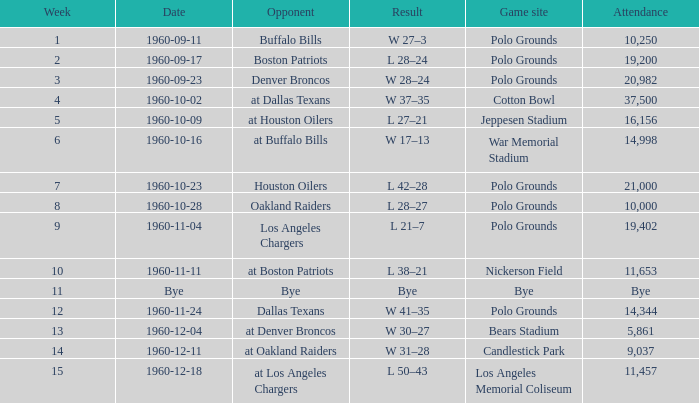What day did they play at candlestick park? 1960-12-11. 